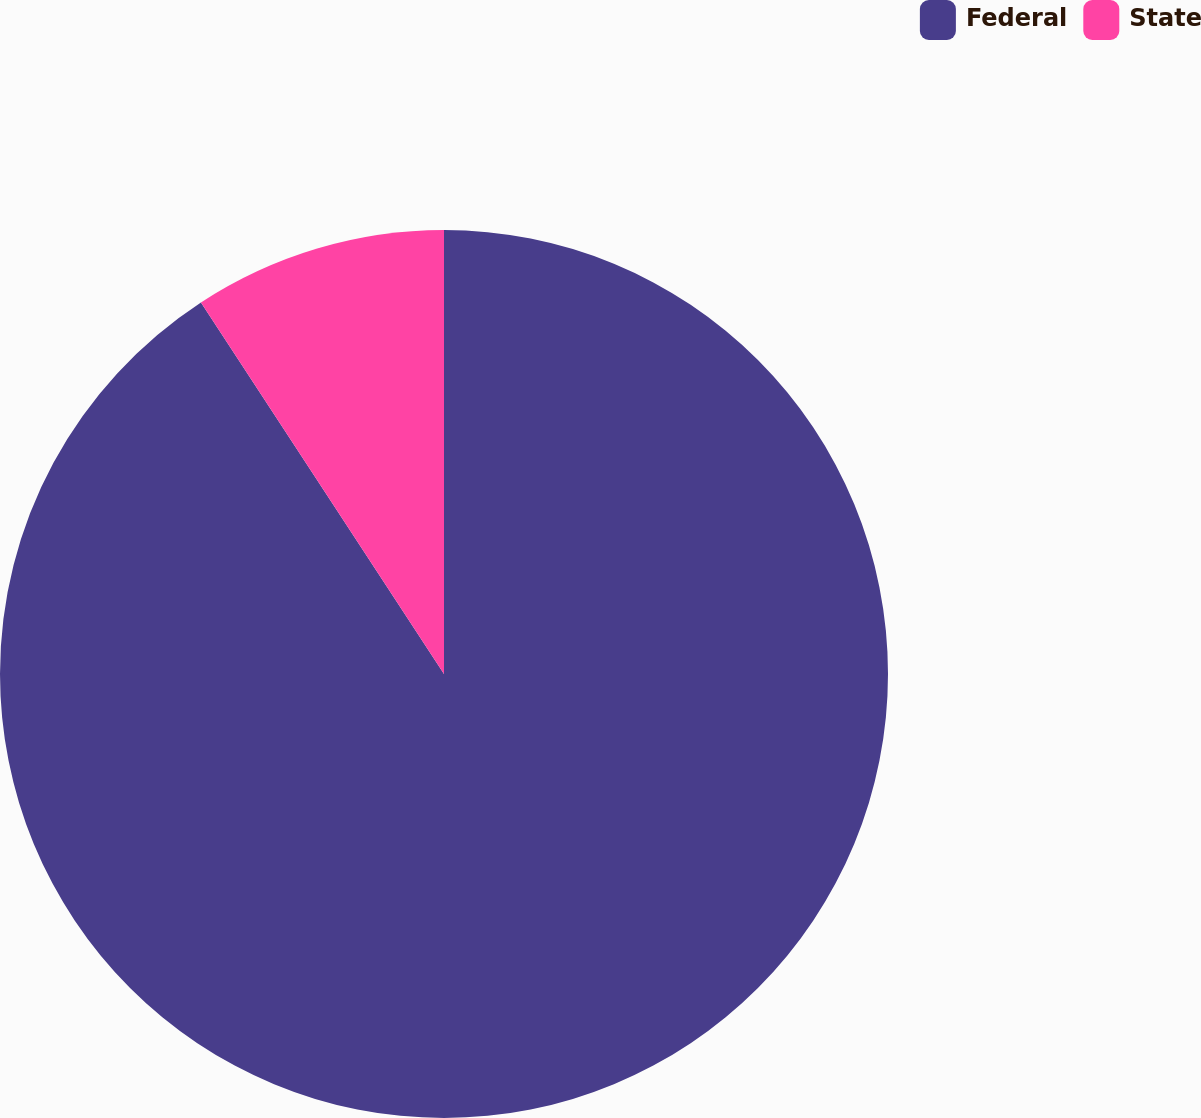<chart> <loc_0><loc_0><loc_500><loc_500><pie_chart><fcel>Federal<fcel>State<nl><fcel>90.78%<fcel>9.22%<nl></chart> 